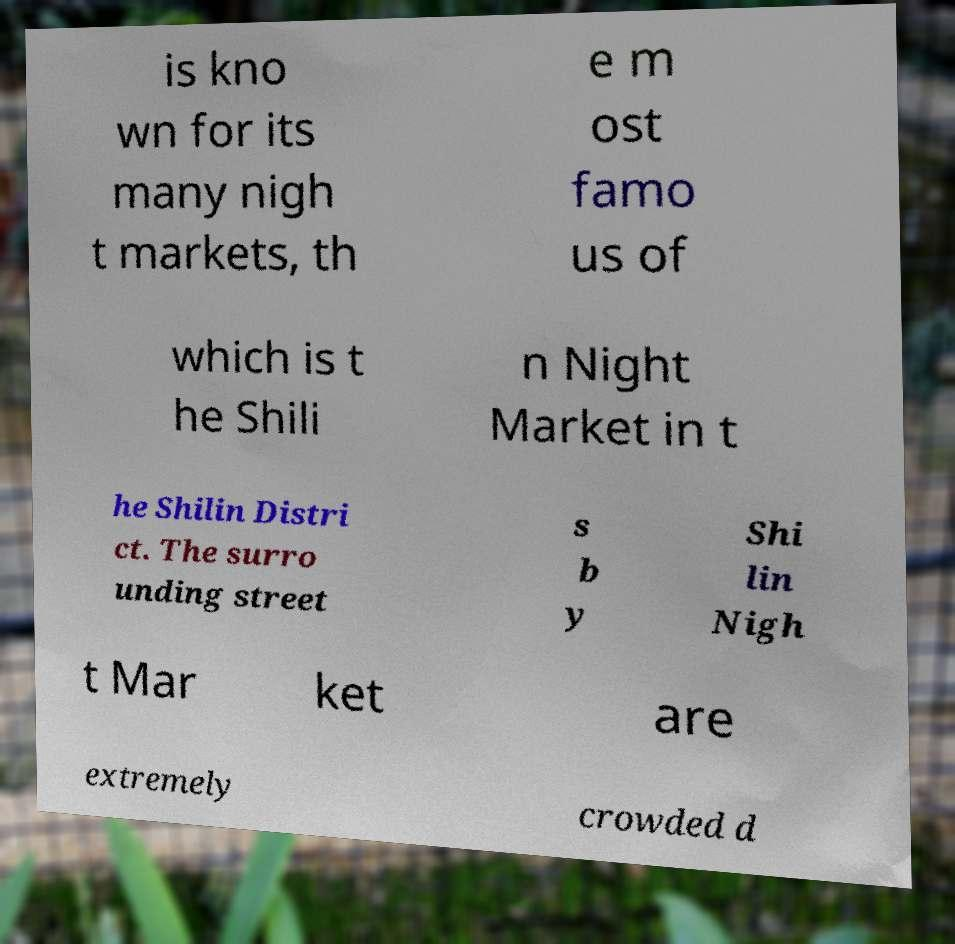Please read and relay the text visible in this image. What does it say? is kno wn for its many nigh t markets, th e m ost famo us of which is t he Shili n Night Market in t he Shilin Distri ct. The surro unding street s b y Shi lin Nigh t Mar ket are extremely crowded d 